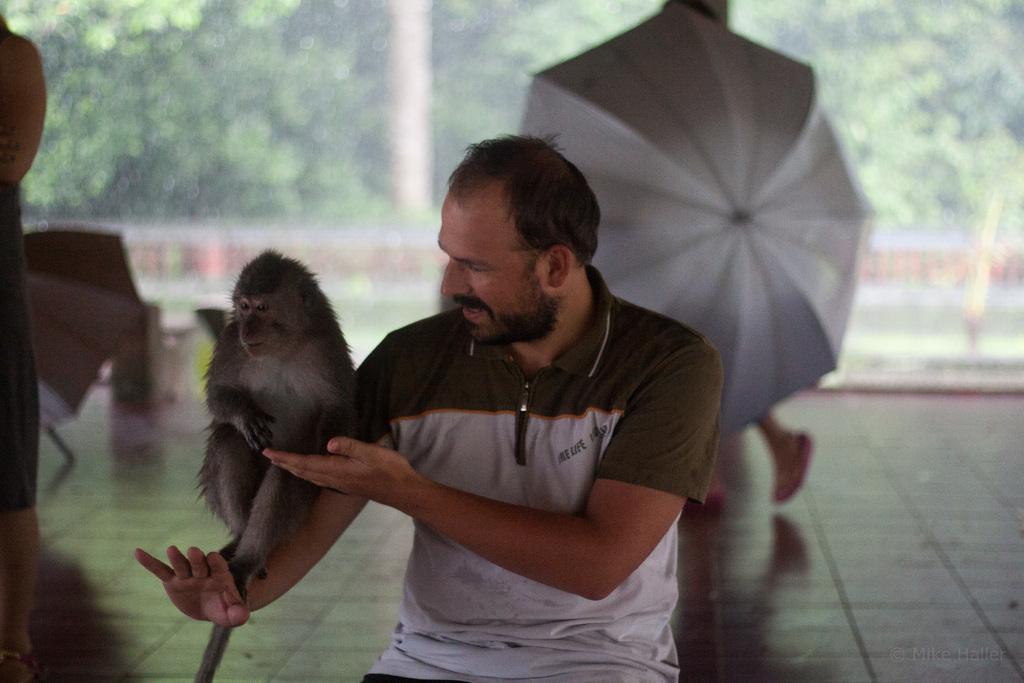Can you describe this image briefly? This picture shows a man playing with a monkey on his hands. In the background there are some people walking with the umbrella. And we can observe some trees here. 